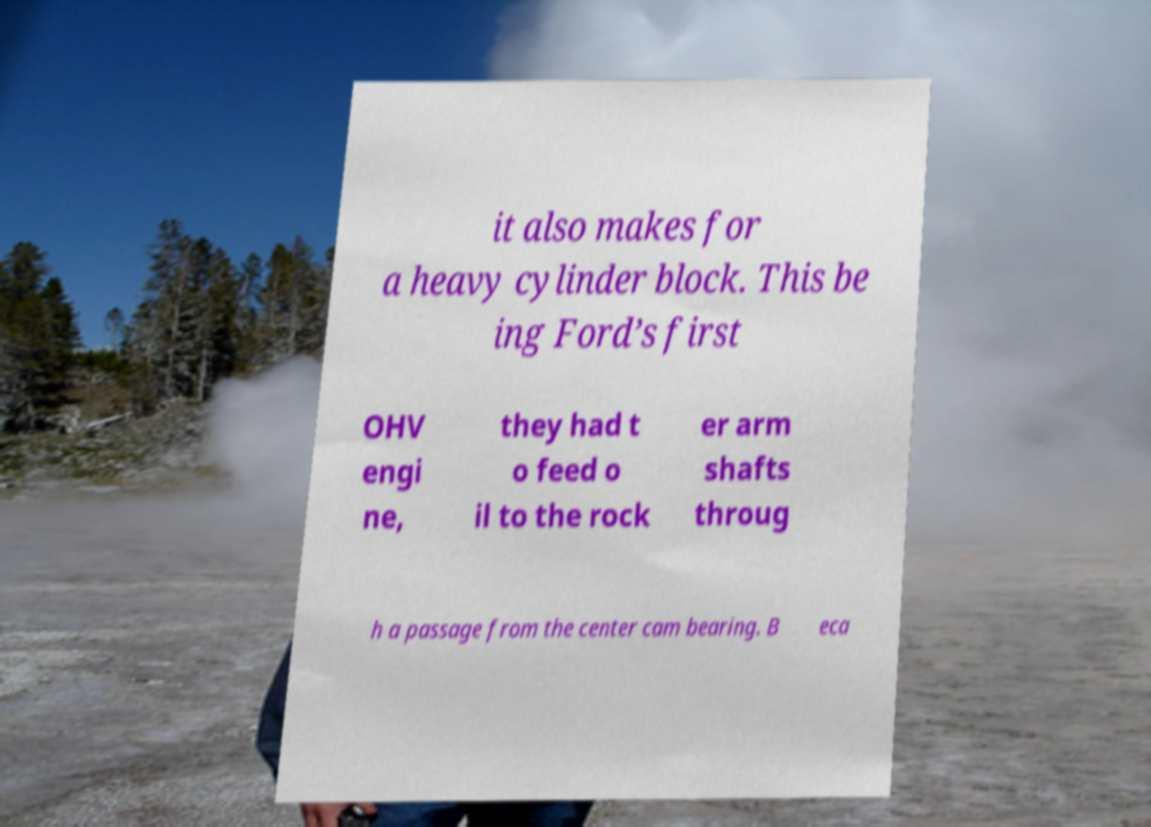I need the written content from this picture converted into text. Can you do that? it also makes for a heavy cylinder block. This be ing Ford’s first OHV engi ne, they had t o feed o il to the rock er arm shafts throug h a passage from the center cam bearing. B eca 